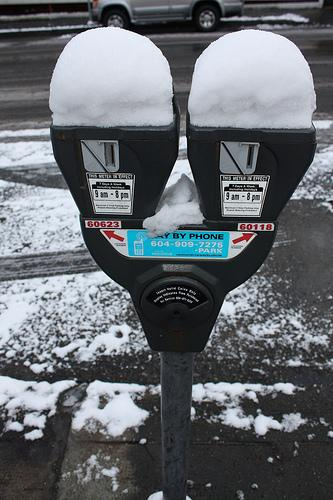Provide a detailed description of the objects in the image. Two snow-laden parking meters share a pole, displaying identity numbers beside a red arrow and a phone number for payments. A silver car is parked on the street, surrounded by a snowy environment. Imagine the image is taken from a movie scene. Describe the scene. In a quiet, snow-filled city scene, a silver car parks along the street, next to snow-capped parking meters - a subtle reminder that life goes on, even on a harsh winter's day. Narrate the image as if it's a scene from a story. Winter's embrace held the city, but life continued. Snow-dusted parking meters guarded the street, silently witnessing a solitary, silver car parked nearby. Write a news headline for the image. Winter Strikes the City: Parking Meters Burdened with Snow, Cars Still Parked on Icy Streets! Imagine this image represents a metaphor. Describe the metaphor. The snow-covered parking meters and car symbolize both the immovable nature of rules and the adaptation of people to various circumstances. Write a poetic description of the image. Upon a white blanket of snow, parking meters stand, adorned with frozen crowns and numbers engraved; silver chariots rest by the icy way. Provide a simple description of the scene in the image. A parking meter with snow on top and numbered stickers on the side is on a snowy sidewalk, and a silver car parked on the street. Describe the most distinctive features or elements in the image. Snow-covered double parking meters with visible numbers, red arrow, and phone payment option stand next to a snowy street with a silver car parked. Describe the weather, objects, and activities in the image. It's a snowy day, and a double parking meter with snow and numbered stickers is on the sidewalk, while a parked silver car sits on the snow-covered street. List five objects or elements you can find in the image. 5. Tire tracks in snow Identify the bicycle parked near the meters. There is no mention of a bicycle in the image, only parking meters and cars. Notice how the parking meter is floating in the air. The parking meter is not floating in the air; it is on the sidewalk. Admire the beautiful sunset in the background. There is no mention of a sunset in the image, only cars, parking meters, and snow. Observe the tree growing next to the parking meter. There is no mention of a tree in the image; the parking meter is on the sidewalk. Can you spot a red car in the image? The car in the image is mentioned as silver, not red. Verify the green arrow pointing down on the parking meter. There is no mention of a green arrow pointing down; there is a red arrow pointing up on the meter instead. Is the parking meter wearing a hat made of leaves? There is no mention of leaves in the image; the parking meter has snow on top instead. Locate a dog playing in the snow near the parking meters. There is no mention of a dog in the image, only parking meters, cars, and snow. Do you see any people walking near the meters? There is no mention of people in the image, only cars and parking meters. The sidewalk is filled with colorful flowers. There are no flowers mentioned in the image, only snow on the sidewalk. 